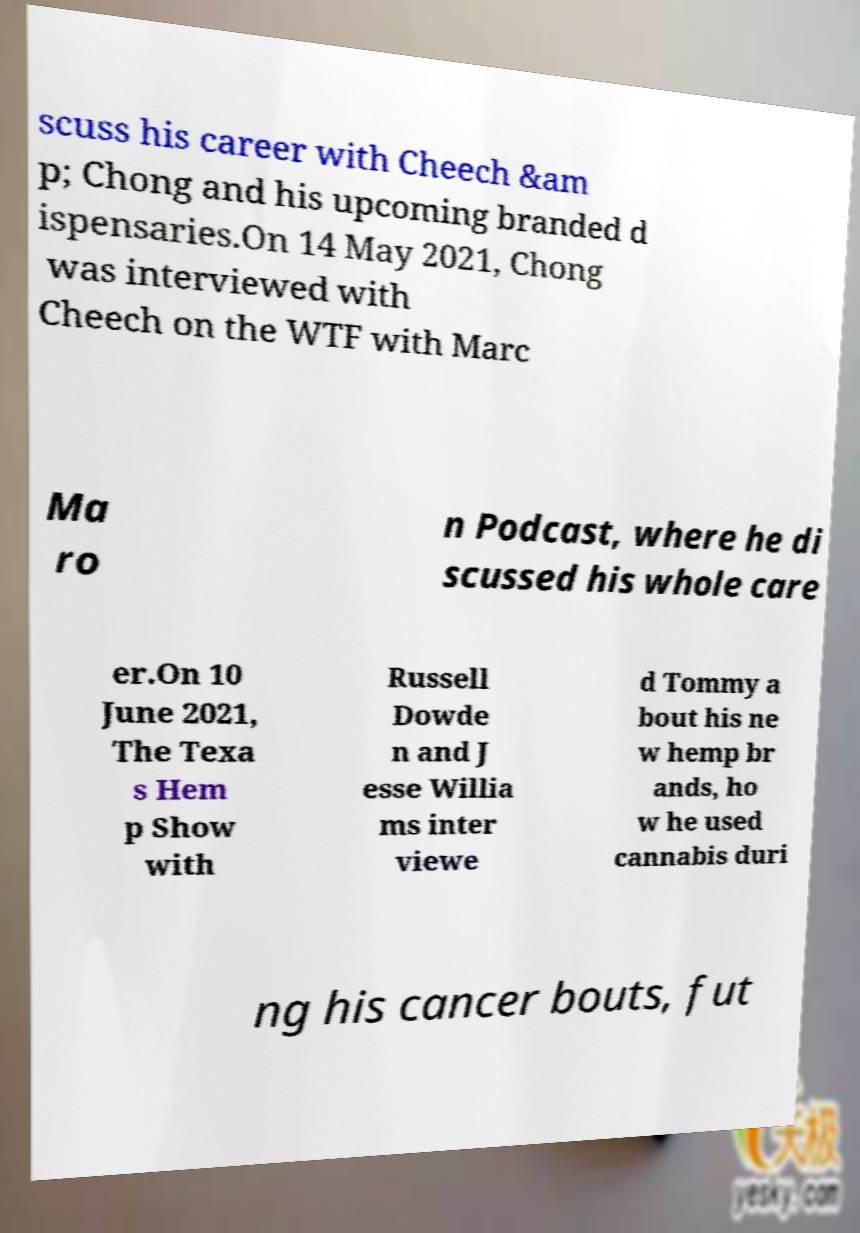Please identify and transcribe the text found in this image. scuss his career with Cheech &am p; Chong and his upcoming branded d ispensaries.On 14 May 2021, Chong was interviewed with Cheech on the WTF with Marc Ma ro n Podcast, where he di scussed his whole care er.On 10 June 2021, The Texa s Hem p Show with Russell Dowde n and J esse Willia ms inter viewe d Tommy a bout his ne w hemp br ands, ho w he used cannabis duri ng his cancer bouts, fut 